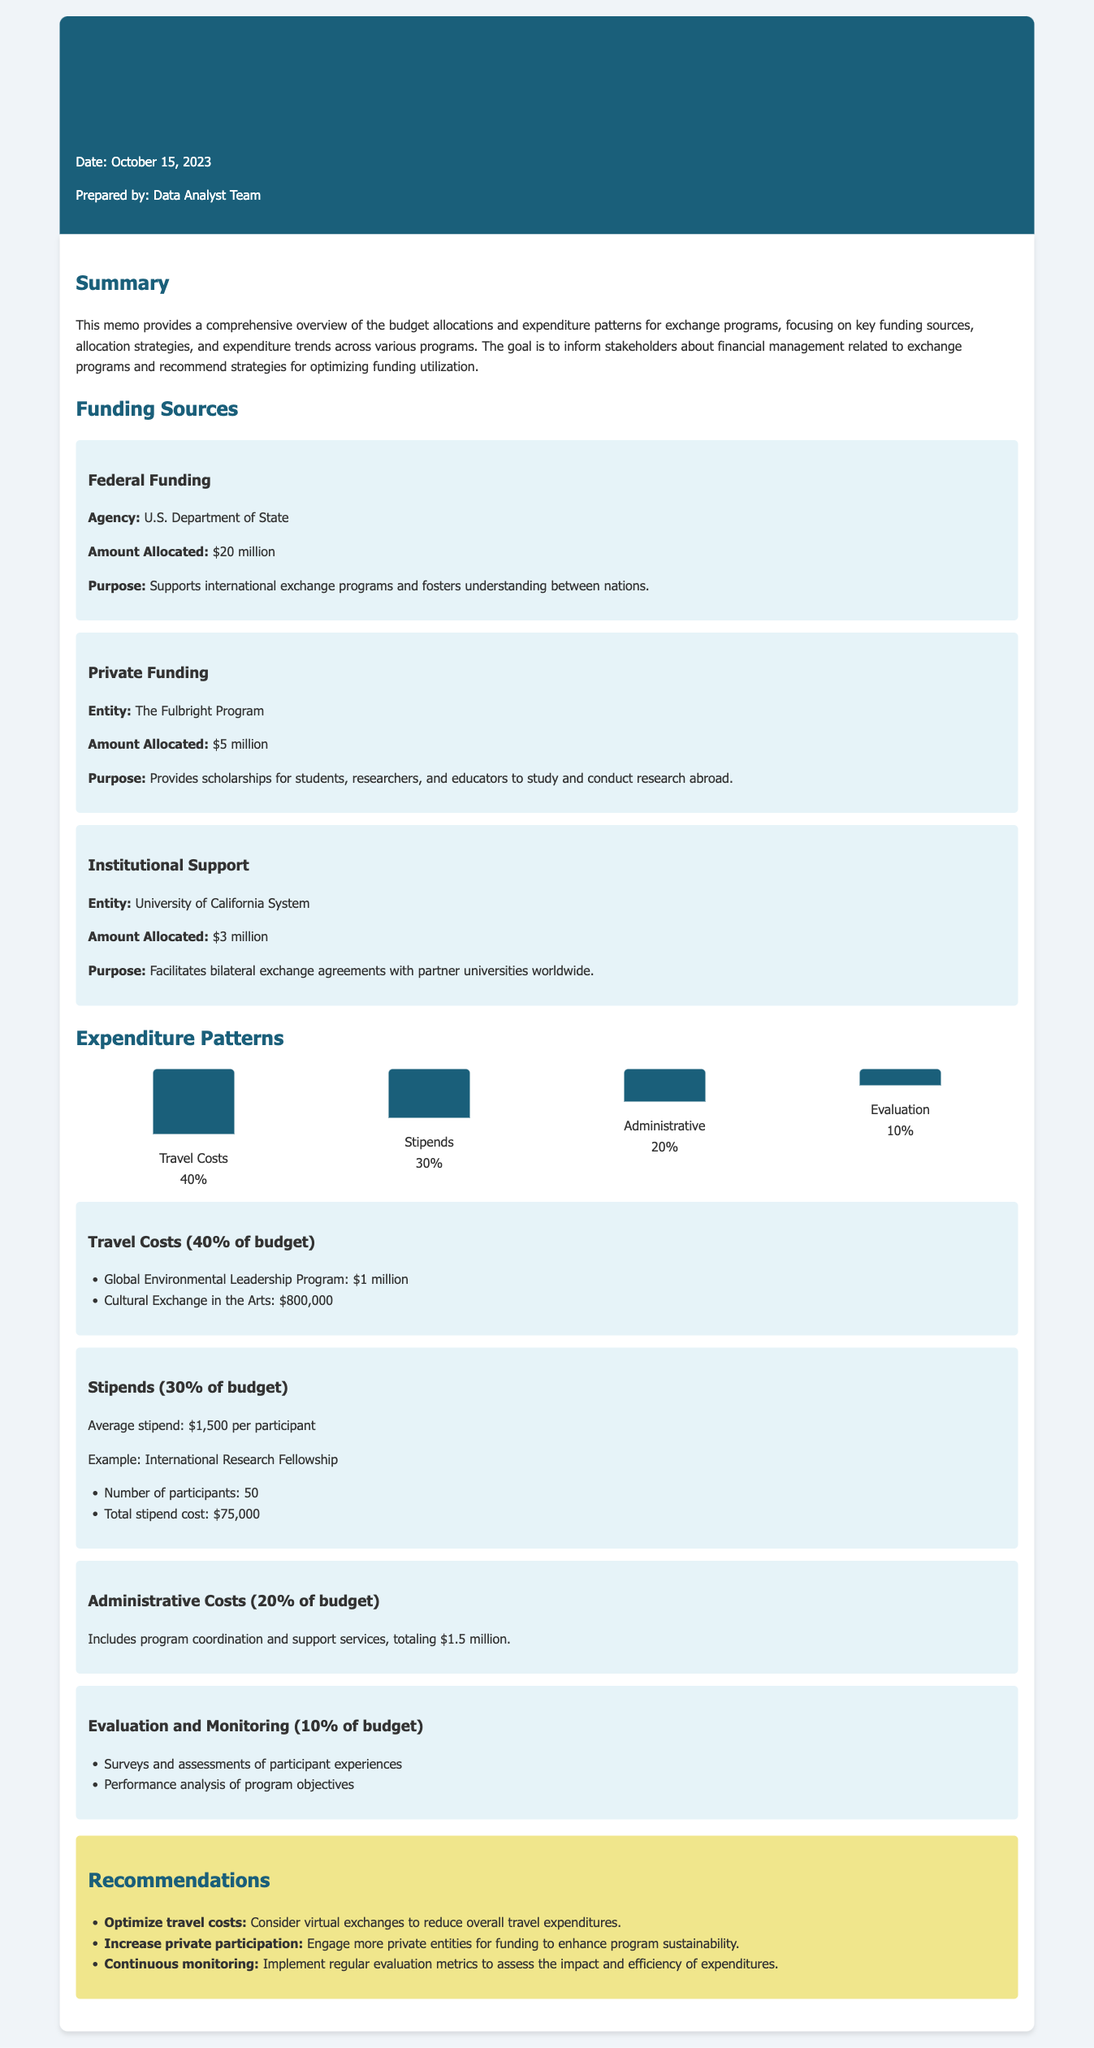what is the total amount allocated for federal funding? The document states that the amount allocated for federal funding is $20 million.
Answer: $20 million what percentage of the budget is allocated to travel costs? The document specifies that travel costs account for 40% of the budget.
Answer: 40% who is the entity providing private funding? The document mentions the Fulbright Program as the entity providing private funding.
Answer: The Fulbright Program what is the average stipend per participant? According to the document, the average stipend per participant is $1,500.
Answer: $1,500 how much is allocated for evaluation and monitoring? The evaluation and monitoring costs are reflected as 10% of the budget, with details provided in the expenditure patterns.
Answer: 10% what agency provides federal funding for the exchange programs? The document identifies the U.S. Department of State as the agency providing federal funding.
Answer: U.S. Department of State what is the total stipend cost for 50 participants in the International Research Fellowship? The document outlines that the total stipend cost for 50 participants is $75,000.
Answer: $75,000 what is one recommendation to optimize costs? The document recommends considering virtual exchanges to reduce overall travel expenditures as one strategy.
Answer: Consider virtual exchanges how much is allocated for administrative costs? The document notes that administrative costs total $1.5 million.
Answer: $1.5 million 